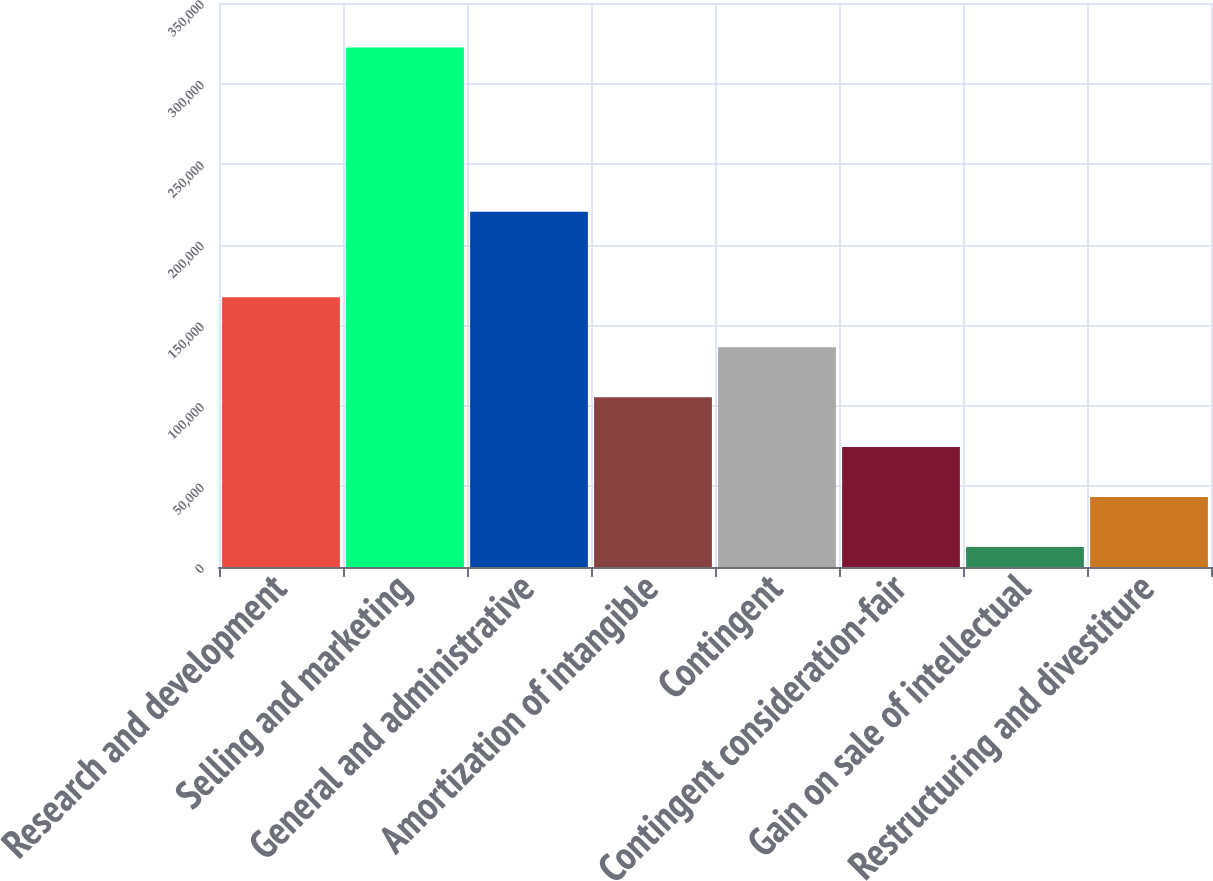Convert chart. <chart><loc_0><loc_0><loc_500><loc_500><bar_chart><fcel>Research and development<fcel>Selling and marketing<fcel>General and administrative<fcel>Amortization of intangible<fcel>Contingent<fcel>Contingent consideration-fair<fcel>Gain on sale of intellectual<fcel>Restructuring and divestiture<nl><fcel>167369<fcel>322314<fcel>220494<fcel>105391<fcel>136380<fcel>74402<fcel>12424<fcel>43413<nl></chart> 